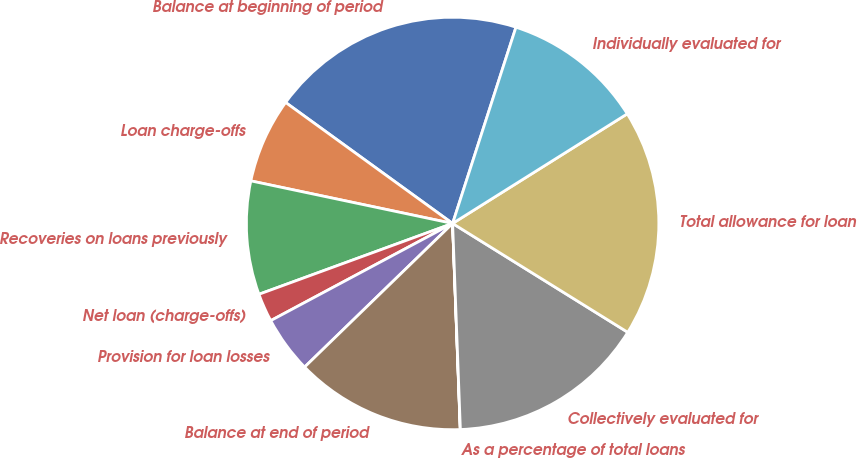<chart> <loc_0><loc_0><loc_500><loc_500><pie_chart><fcel>Balance at beginning of period<fcel>Loan charge-offs<fcel>Recoveries on loans previously<fcel>Net loan (charge-offs)<fcel>Provision for loan losses<fcel>Balance at end of period<fcel>As a percentage of total loans<fcel>Collectively evaluated for<fcel>Total allowance for loan<fcel>Individually evaluated for<nl><fcel>19.99%<fcel>6.67%<fcel>8.89%<fcel>2.23%<fcel>4.45%<fcel>13.33%<fcel>0.01%<fcel>15.55%<fcel>17.77%<fcel>11.11%<nl></chart> 